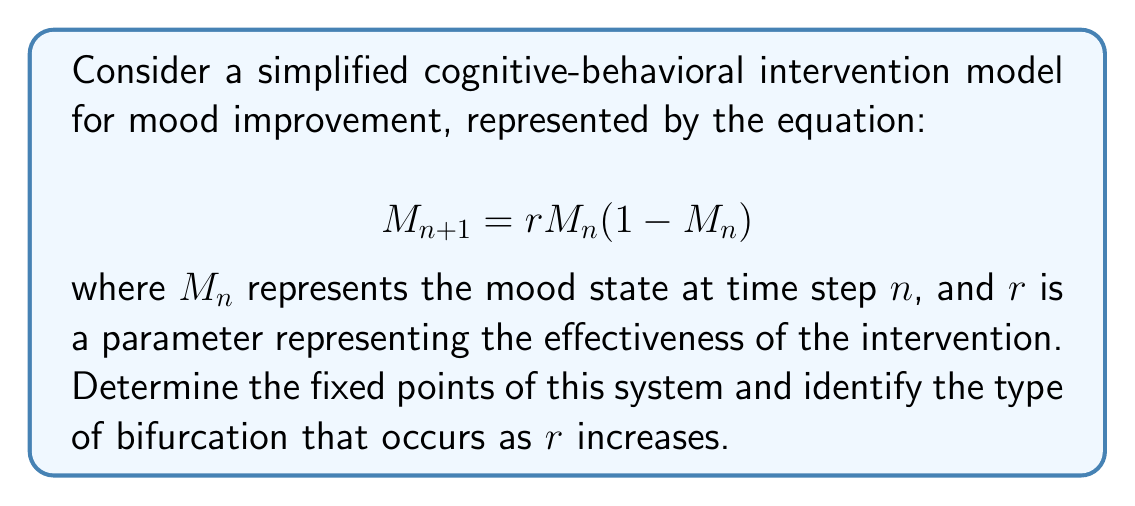Help me with this question. 1. To find the fixed points, we set $M_{n+1} = M_n = M^*$:

   $$M^* = rM^*(1-M^*)$$

2. Solve this equation:
   $$M^* = rM^* - rM^{*2}$$
   $$0 = rM^* - rM^{*2} - M^*$$
   $$0 = M^*(r - rM^* - 1)$$

3. We get two solutions:
   a) $M^* = 0$
   b) $r - rM^* - 1 = 0$, which gives $M^* = \frac{r-1}{r}$

4. The fixed points are:
   $$M^*_1 = 0 \text{ and } M^*_2 = \frac{r-1}{r}$$

5. To determine stability, we calculate the derivative of the function at each fixed point:
   $$f'(M) = r - 2rM$$

   At $M^*_1 = 0$: $f'(0) = r$
   At $M^*_2 = \frac{r-1}{r}$: $f'(\frac{r-1}{r}) = 2 - r$

6. The stability changes when $|f'(M^*)| = 1$:
   For $M^*_1$: $|r| = 1$, so $r = 1$ or $r = -1$
   For $M^*_2$: $|2-r| = 1$, so $r = 1$ or $r = 3$

7. As $r$ increases from 0, we observe:
   - For $0 < r < 1$, only $M^*_1 = 0$ exists and is stable.
   - At $r = 1$, $M^*_1$ and $M^*_2$ coincide at 0.
   - For $1 < r < 3$, $M^*_1 = 0$ becomes unstable, and $M^*_2 = \frac{r-1}{r}$ is stable.

8. This behavior indicates a transcritical bifurcation at $r = 1$, where the two fixed points exchange stability.
Answer: Fixed points: $M^*_1 = 0$, $M^*_2 = \frac{r-1}{r}$; Transcritical bifurcation at $r = 1$. 